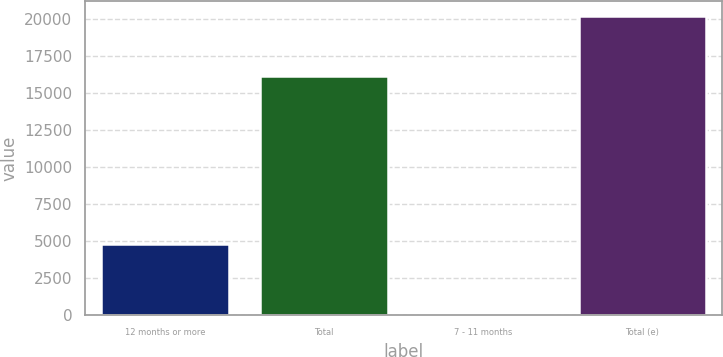Convert chart to OTSL. <chart><loc_0><loc_0><loc_500><loc_500><bar_chart><fcel>12 months or more<fcel>Total<fcel>7 - 11 months<fcel>Total (e)<nl><fcel>4830<fcel>16160<fcel>175<fcel>20226<nl></chart> 